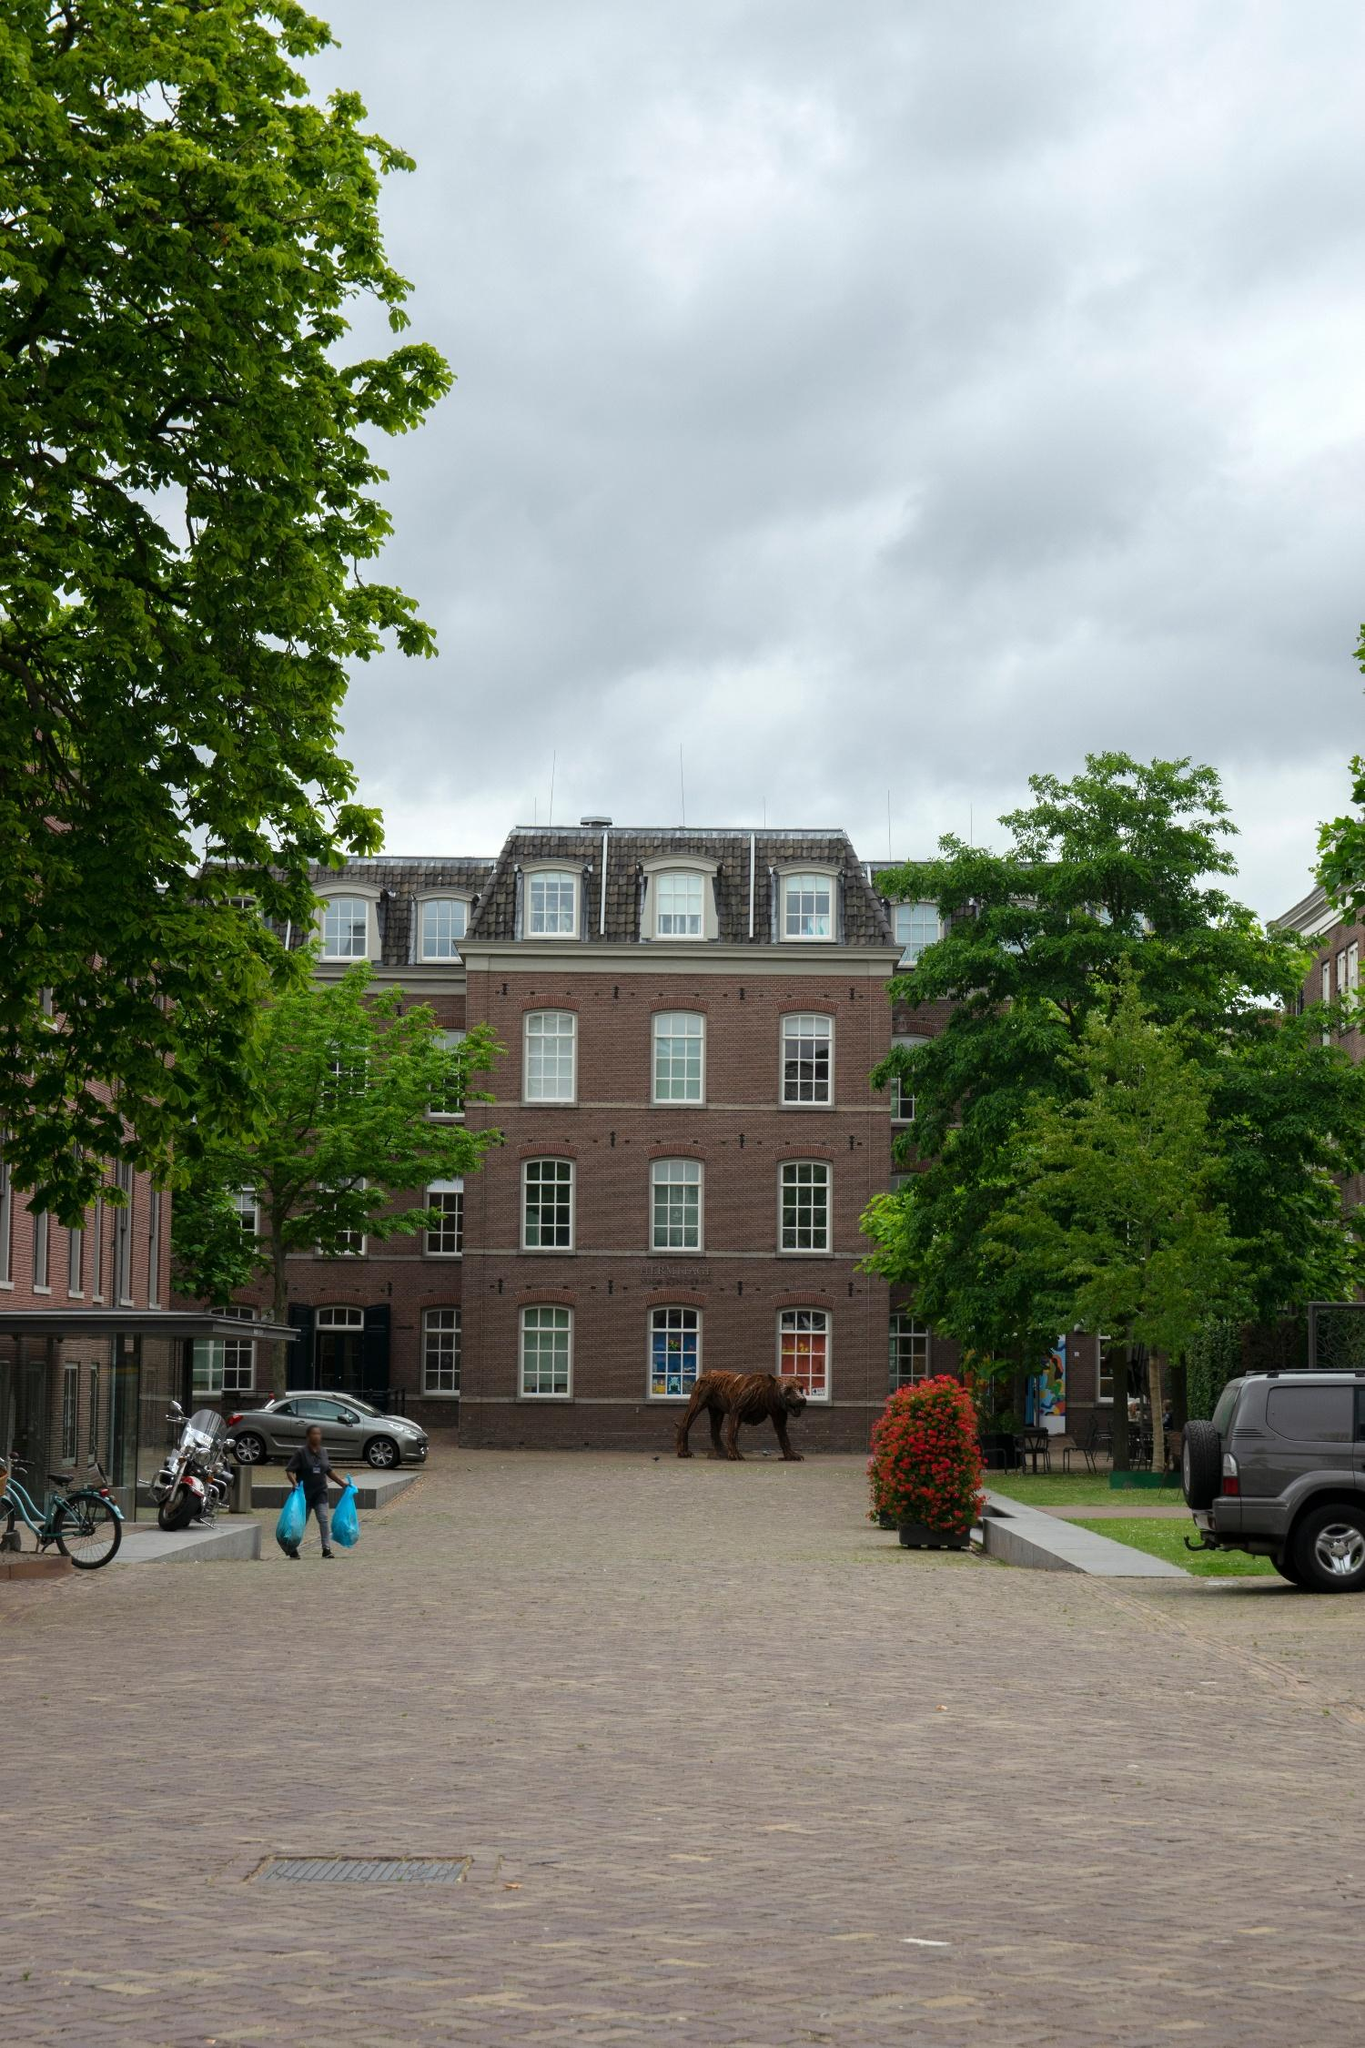Imagine the bear sculpture comes to life at night. What might its nocturnal adventures entail? If the bear sculpture came to life at night, it might silently prowl the quiet, cobblestone streets, exploring its surroundings with newfound curiosity. It could visit the nearby park, marveling at the flora and fauna under the moonlight. The bear might also venture into the heart of the neighborhood, observing the night-life from the shadows, perhaps even sneaking a peek into the windows of the cozy homes. It might engage in gentle mischief, rearranging potted plants, or leaving mysterious footprints in the morning dew. By dawn, it would return to its spot, reverting to a sculpture, leaving behind stories of its nocturnal escapades that only the most imaginative residents could conceive. 